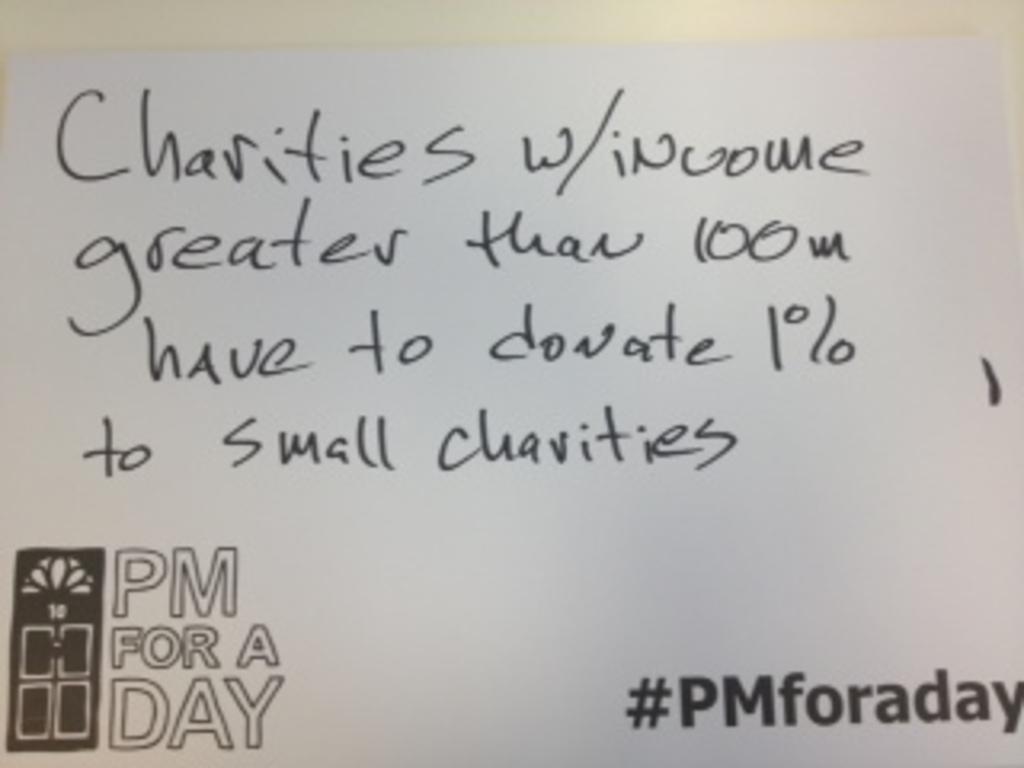Describe this image in one or two sentences. In this picture we can observe black color text on the paper. The paper is in white color. 